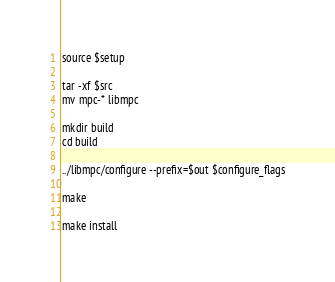Convert code to text. <code><loc_0><loc_0><loc_500><loc_500><_Bash_>source $setup

tar -xf $src
mv mpc-* libmpc

mkdir build
cd build

../libmpc/configure --prefix=$out $configure_flags

make

make install
</code> 